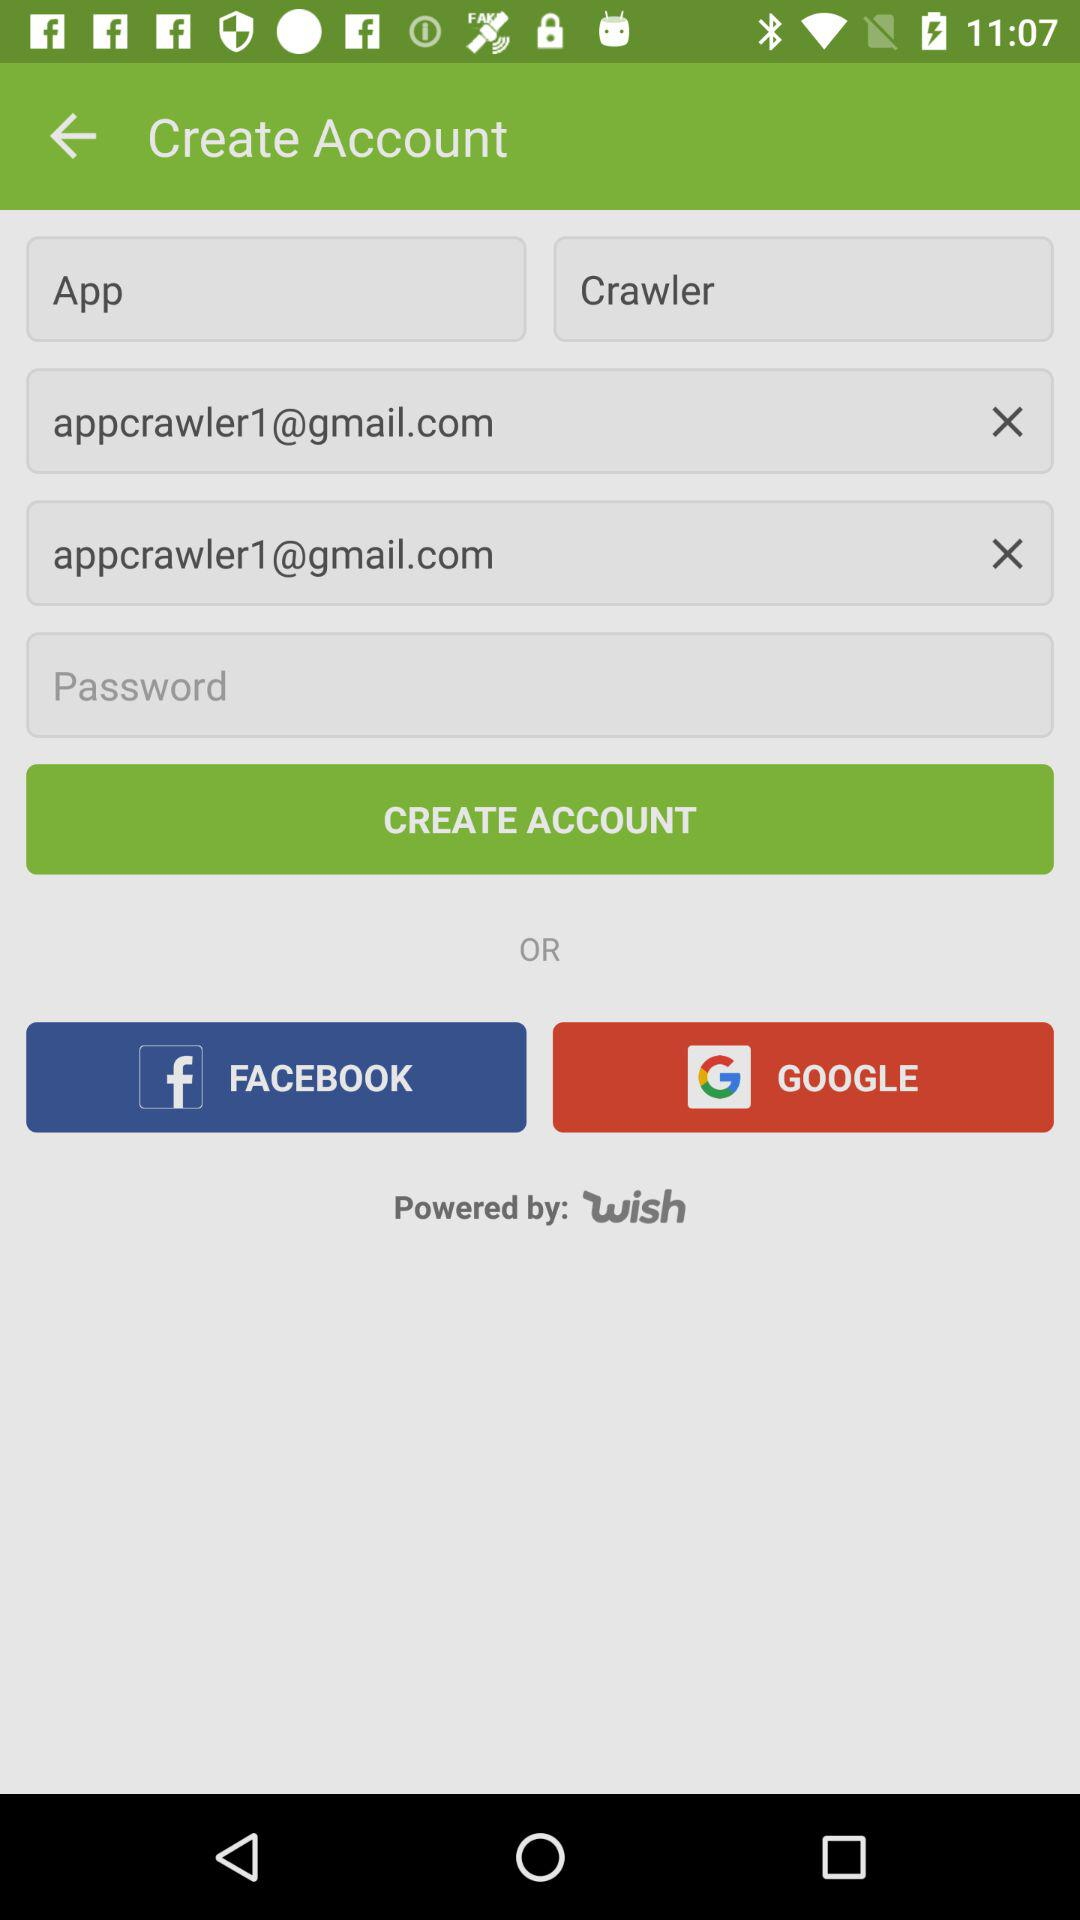Which applications can be used to create the account? The applications that can be used to create the account are "FACEBOOK" and "GOOGLE". 